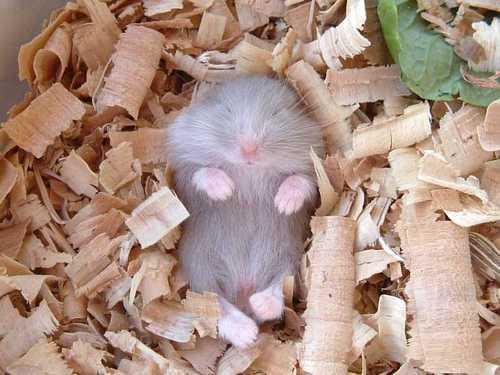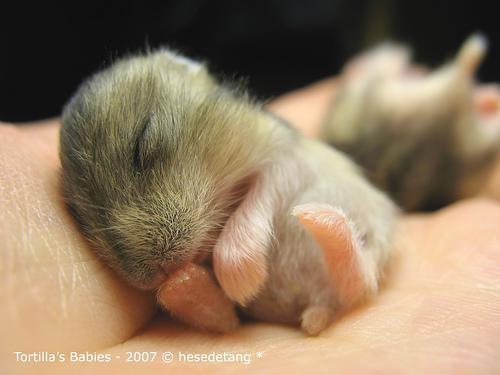The first image is the image on the left, the second image is the image on the right. For the images displayed, is the sentence "There is exactly one sleeping rodent in the hand of a human in the image on the right." factually correct? Answer yes or no. No. 